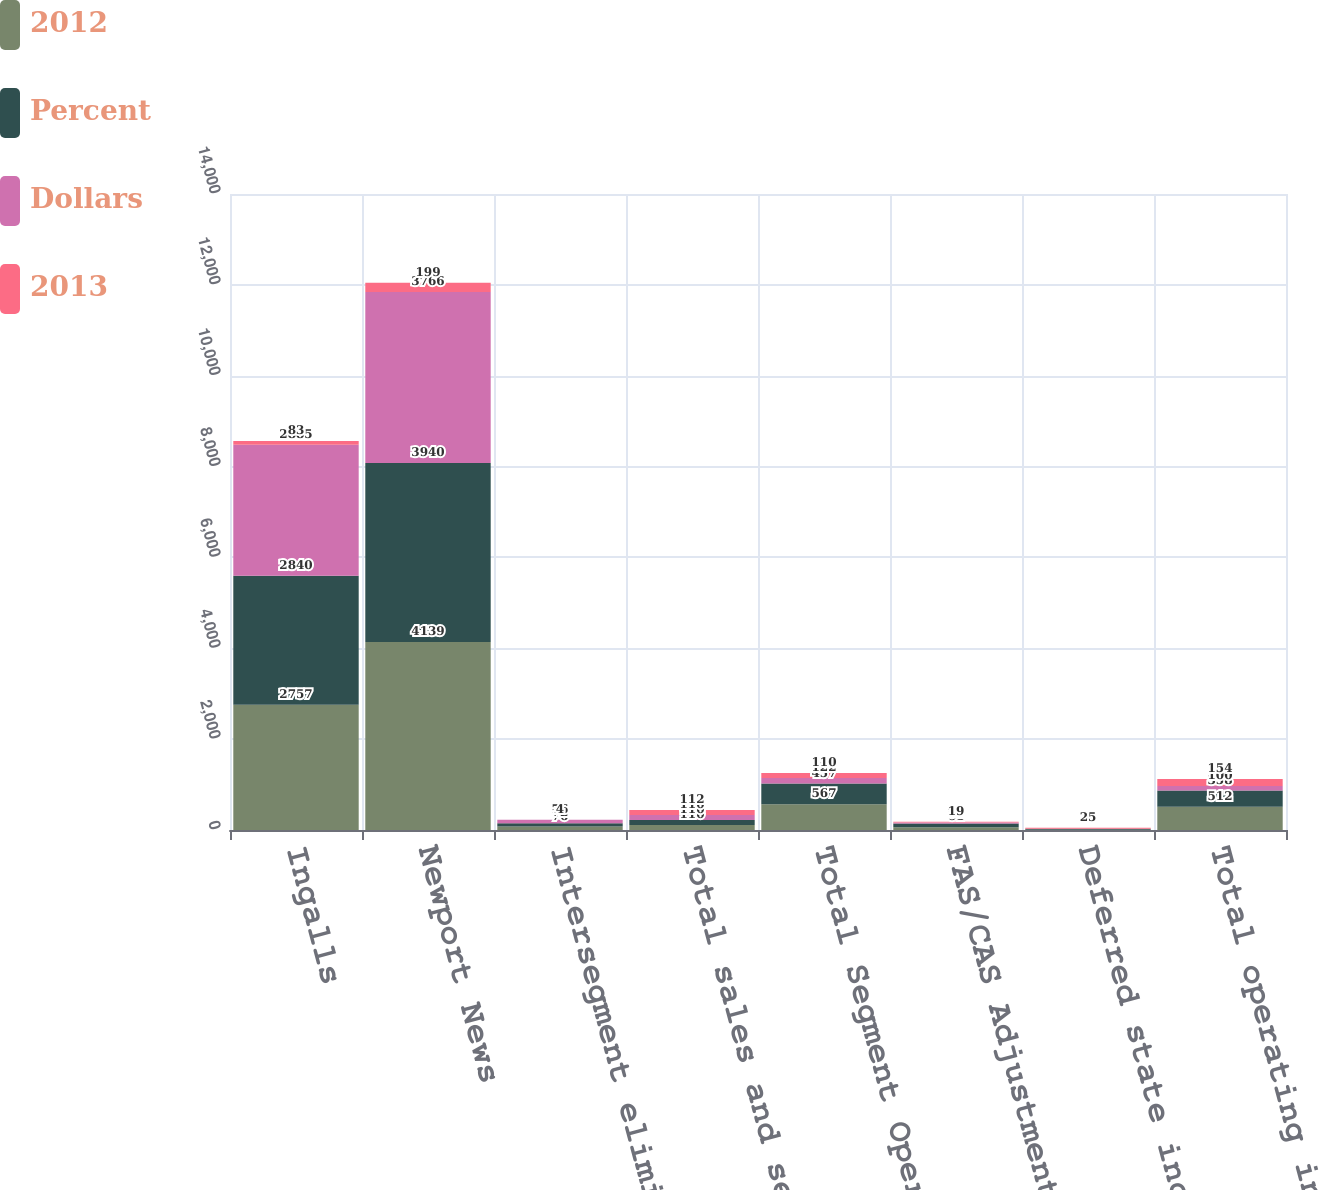Convert chart. <chart><loc_0><loc_0><loc_500><loc_500><stacked_bar_chart><ecel><fcel>Ingalls<fcel>Newport News<fcel>Intersegment eliminations<fcel>Total sales and service<fcel>Total Segment Operating Income<fcel>FAS/CAS Adjustment<fcel>Deferred state income taxes<fcel>Total operating income (loss)<nl><fcel>2012<fcel>2757<fcel>4139<fcel>76<fcel>110<fcel>567<fcel>61<fcel>6<fcel>512<nl><fcel>Percent<fcel>2840<fcel>3940<fcel>72<fcel>110<fcel>457<fcel>80<fcel>19<fcel>358<nl><fcel>Dollars<fcel>2885<fcel>3766<fcel>76<fcel>110<fcel>122<fcel>23<fcel>1<fcel>100<nl><fcel>2013<fcel>83<fcel>199<fcel>4<fcel>112<fcel>110<fcel>19<fcel>25<fcel>154<nl></chart> 